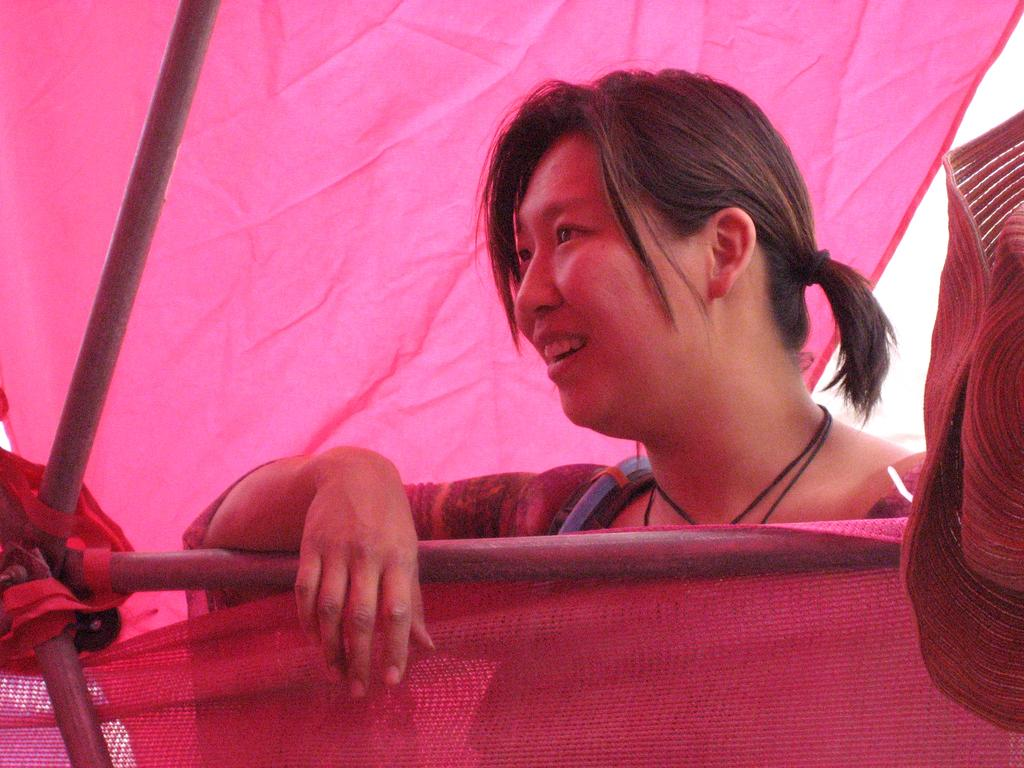Who is present in the image? There is a woman in the image. What is the woman wearing? The woman is wearing clothes and a necklace. What is the woman's facial expression? The woman is smiling. What other objects can be seen in the image? There is a rod and a pink cloth in the image. What type of thread is being used to sew the sky in the image? There is no sky or thread present in the image. 